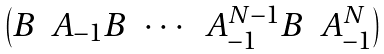<formula> <loc_0><loc_0><loc_500><loc_500>\begin{pmatrix} B & A _ { - 1 } B & \cdots & A _ { - 1 } ^ { N - 1 } B & A _ { - 1 } ^ { N } \end{pmatrix}</formula> 